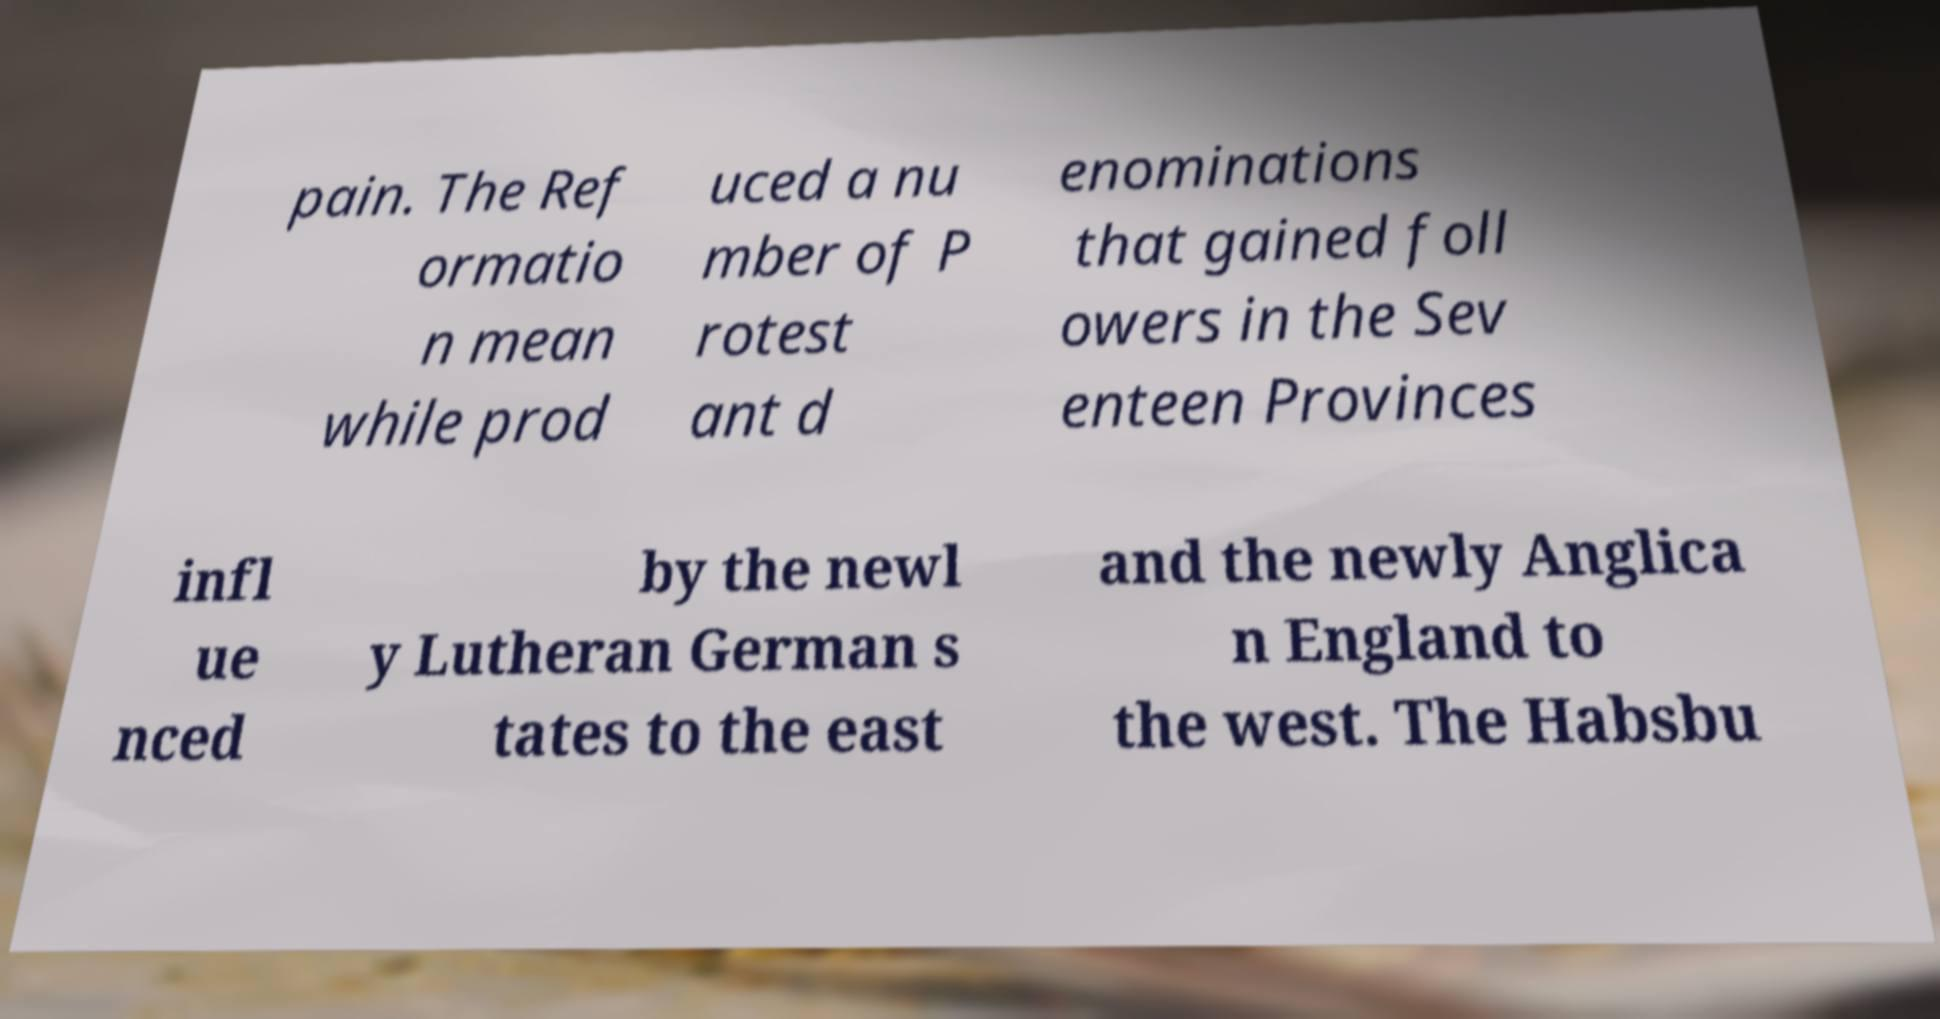What messages or text are displayed in this image? I need them in a readable, typed format. pain. The Ref ormatio n mean while prod uced a nu mber of P rotest ant d enominations that gained foll owers in the Sev enteen Provinces infl ue nced by the newl y Lutheran German s tates to the east and the newly Anglica n England to the west. The Habsbu 